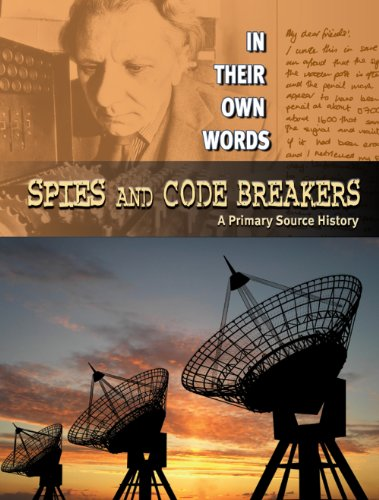Who wrote this book? The book was written by Carey Scott, a known author in historical and educational literature. 